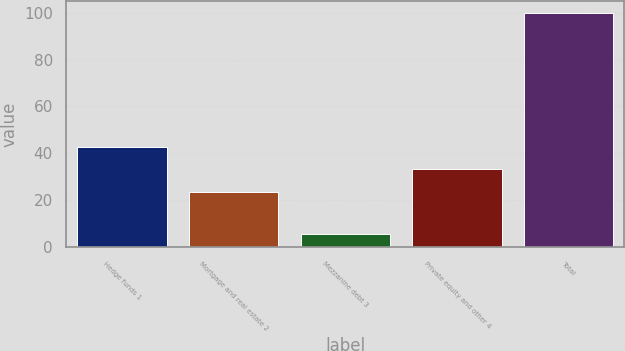Convert chart to OTSL. <chart><loc_0><loc_0><loc_500><loc_500><bar_chart><fcel>Hedge funds 1<fcel>Mortgage and real estate 2<fcel>Mezzanine debt 3<fcel>Private equity and other 4<fcel>Total<nl><fcel>42.6<fcel>23.7<fcel>5.5<fcel>33.15<fcel>100<nl></chart> 